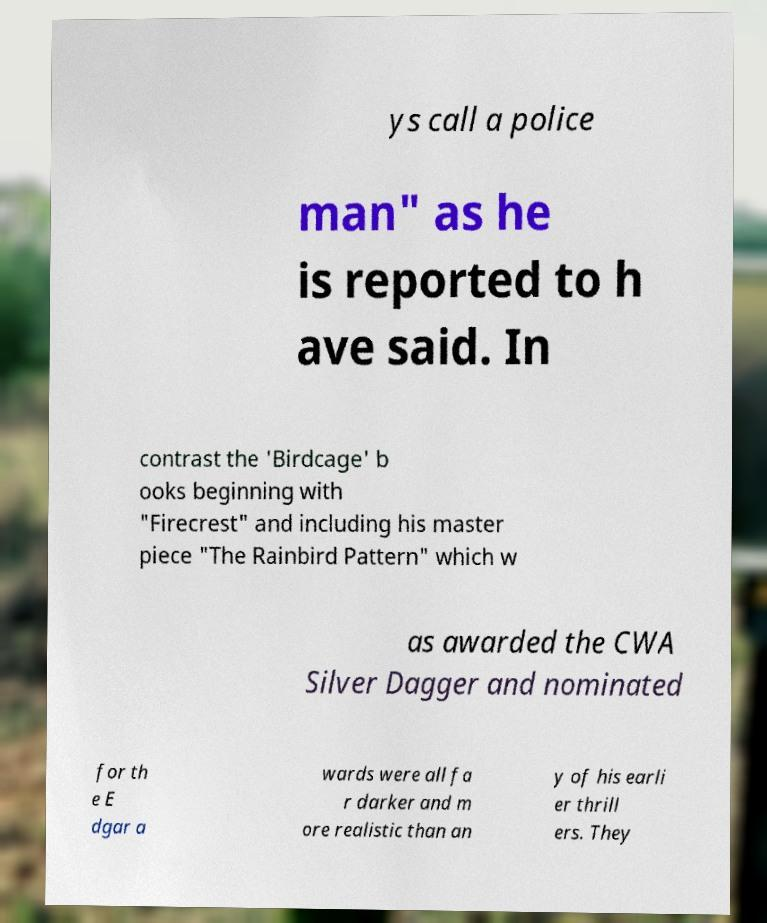For documentation purposes, I need the text within this image transcribed. Could you provide that? ys call a police man" as he is reported to h ave said. In contrast the 'Birdcage' b ooks beginning with "Firecrest" and including his master piece "The Rainbird Pattern" which w as awarded the CWA Silver Dagger and nominated for th e E dgar a wards were all fa r darker and m ore realistic than an y of his earli er thrill ers. They 